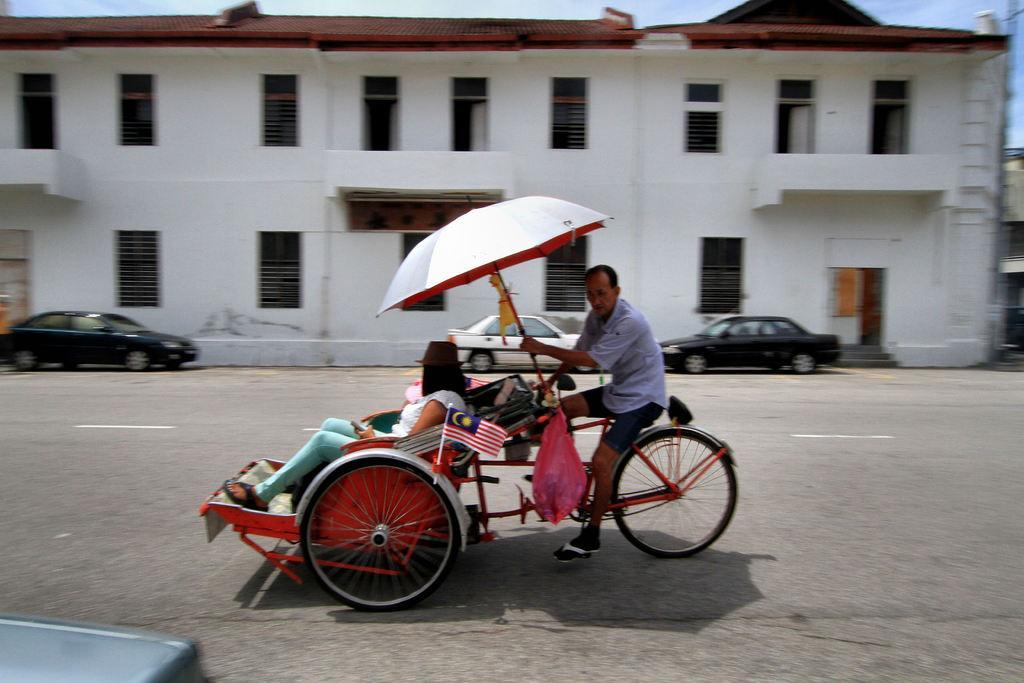Please provide a concise description of this image. This picture is taken from the outside of the city. In this image, in the middle, we can see a man riding a bicycle and holding an umbrella in his hand. In the vehicle, we can also see a person sitting. In the left corner, we can see a black color object. In the background, we can see few cars which are placed on the road. In the background, we can also see a building, window. At the top, we can see a sky, at the bottom, we can see a road. 